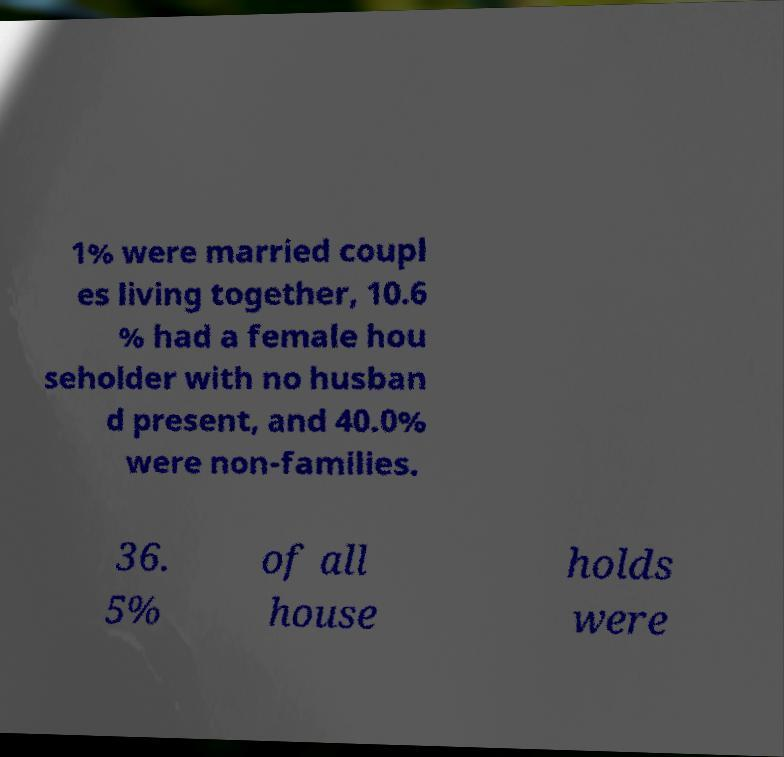Can you accurately transcribe the text from the provided image for me? 1% were married coupl es living together, 10.6 % had a female hou seholder with no husban d present, and 40.0% were non-families. 36. 5% of all house holds were 